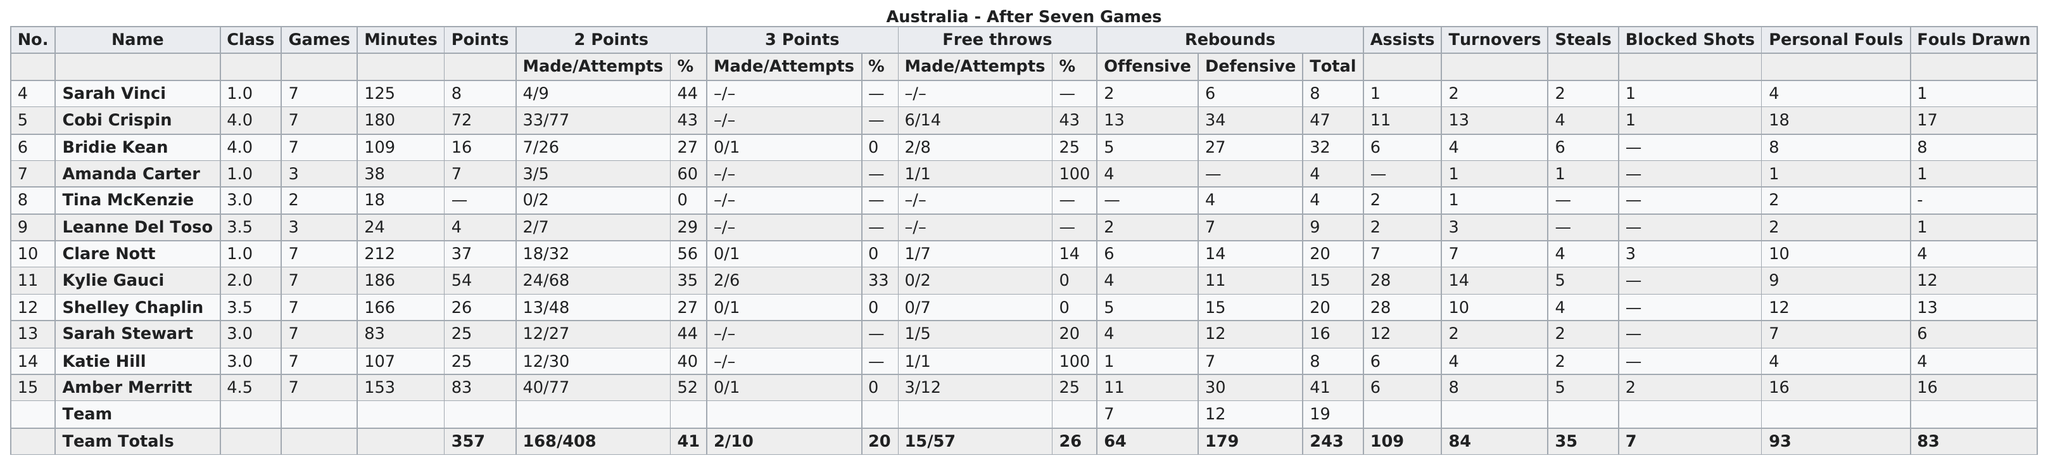Mention a couple of crucial points in this snapshot. The top scorer at the event was Cobi Crispin, who was next to Merritt. Amber Merritt, who had the most total points, is the player to which we are referring. The total number of free throws attempted was 57. Bridie Kean, who had more steals than any other player, was the clear standout in this category. Tina McKenzie is the first person on the list who played less than 20 minutes. 